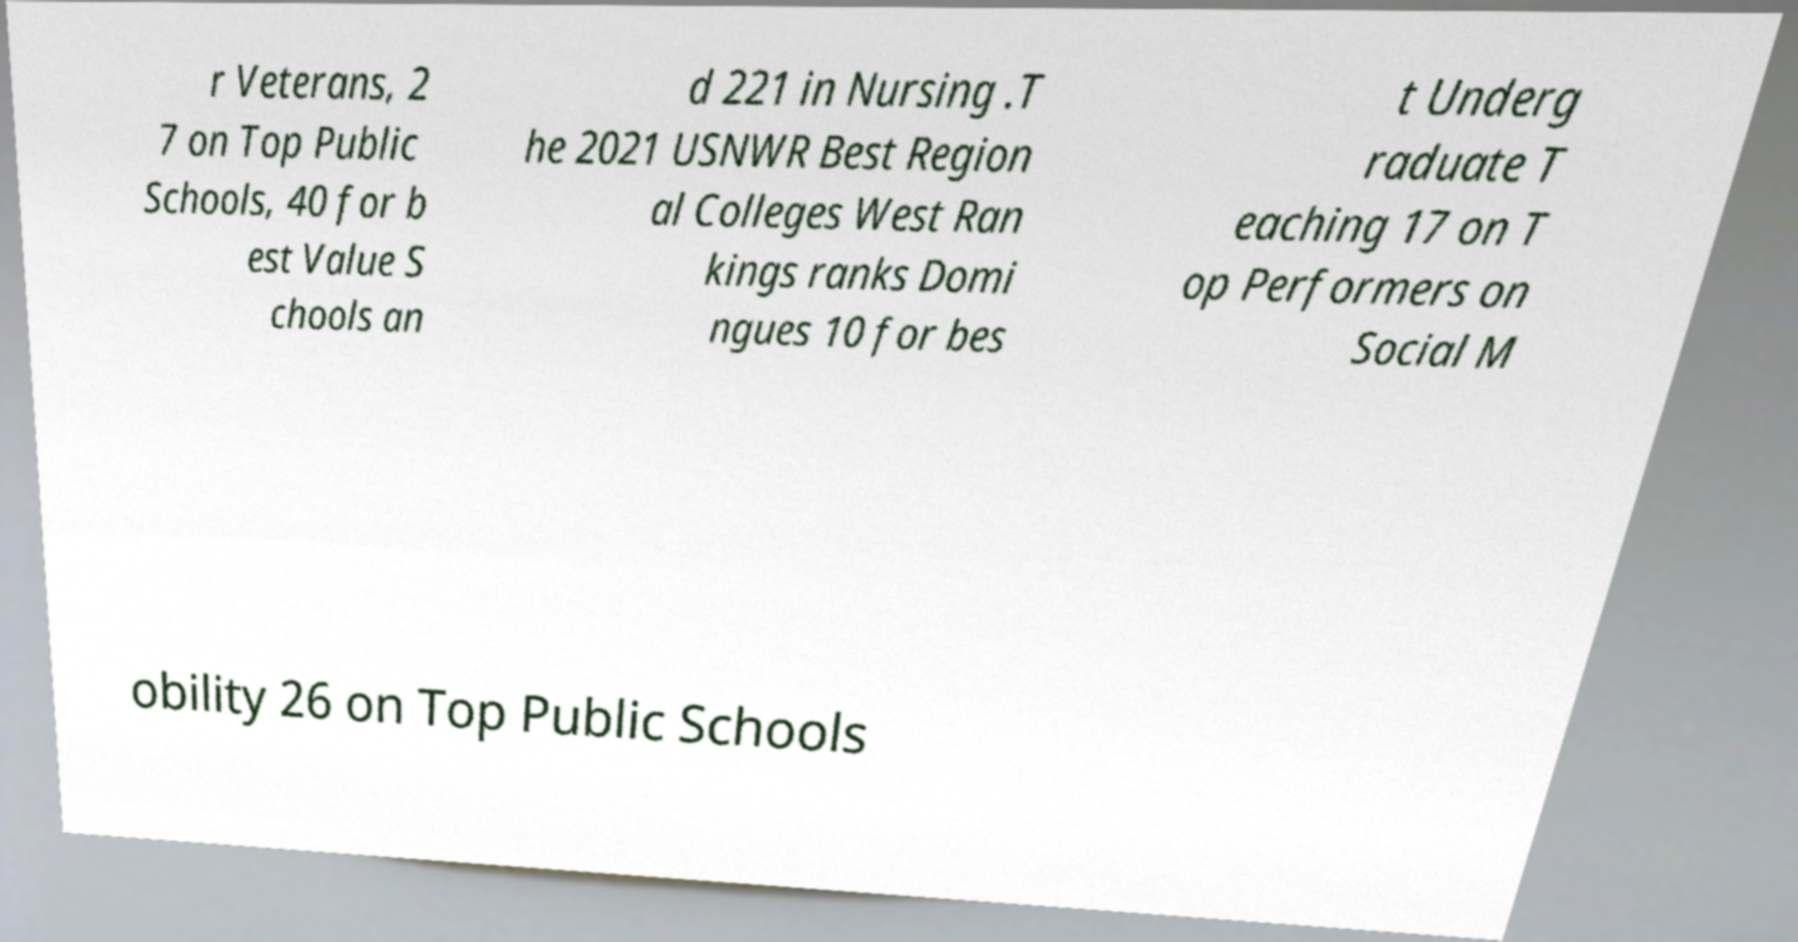Please identify and transcribe the text found in this image. r Veterans, 2 7 on Top Public Schools, 40 for b est Value S chools an d 221 in Nursing .T he 2021 USNWR Best Region al Colleges West Ran kings ranks Domi ngues 10 for bes t Underg raduate T eaching 17 on T op Performers on Social M obility 26 on Top Public Schools 